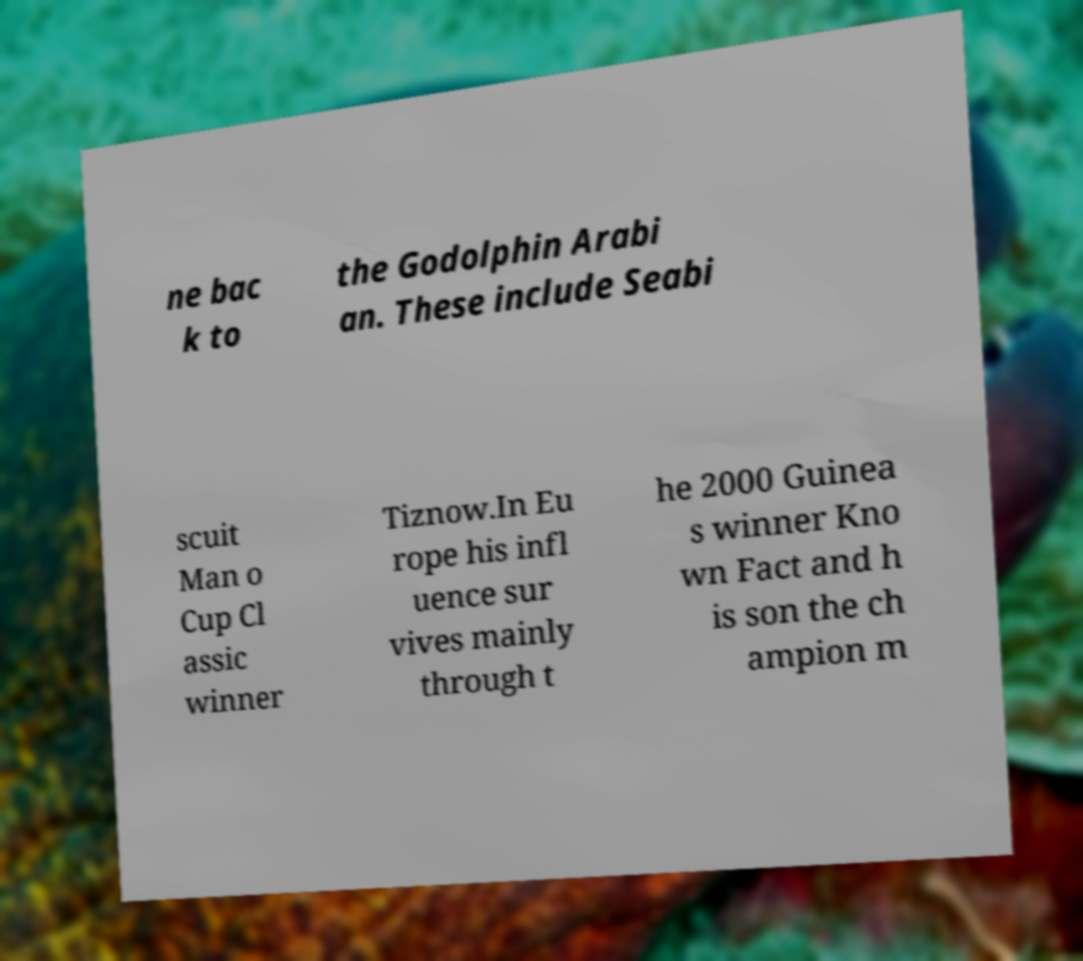What messages or text are displayed in this image? I need them in a readable, typed format. ne bac k to the Godolphin Arabi an. These include Seabi scuit Man o Cup Cl assic winner Tiznow.In Eu rope his infl uence sur vives mainly through t he 2000 Guinea s winner Kno wn Fact and h is son the ch ampion m 